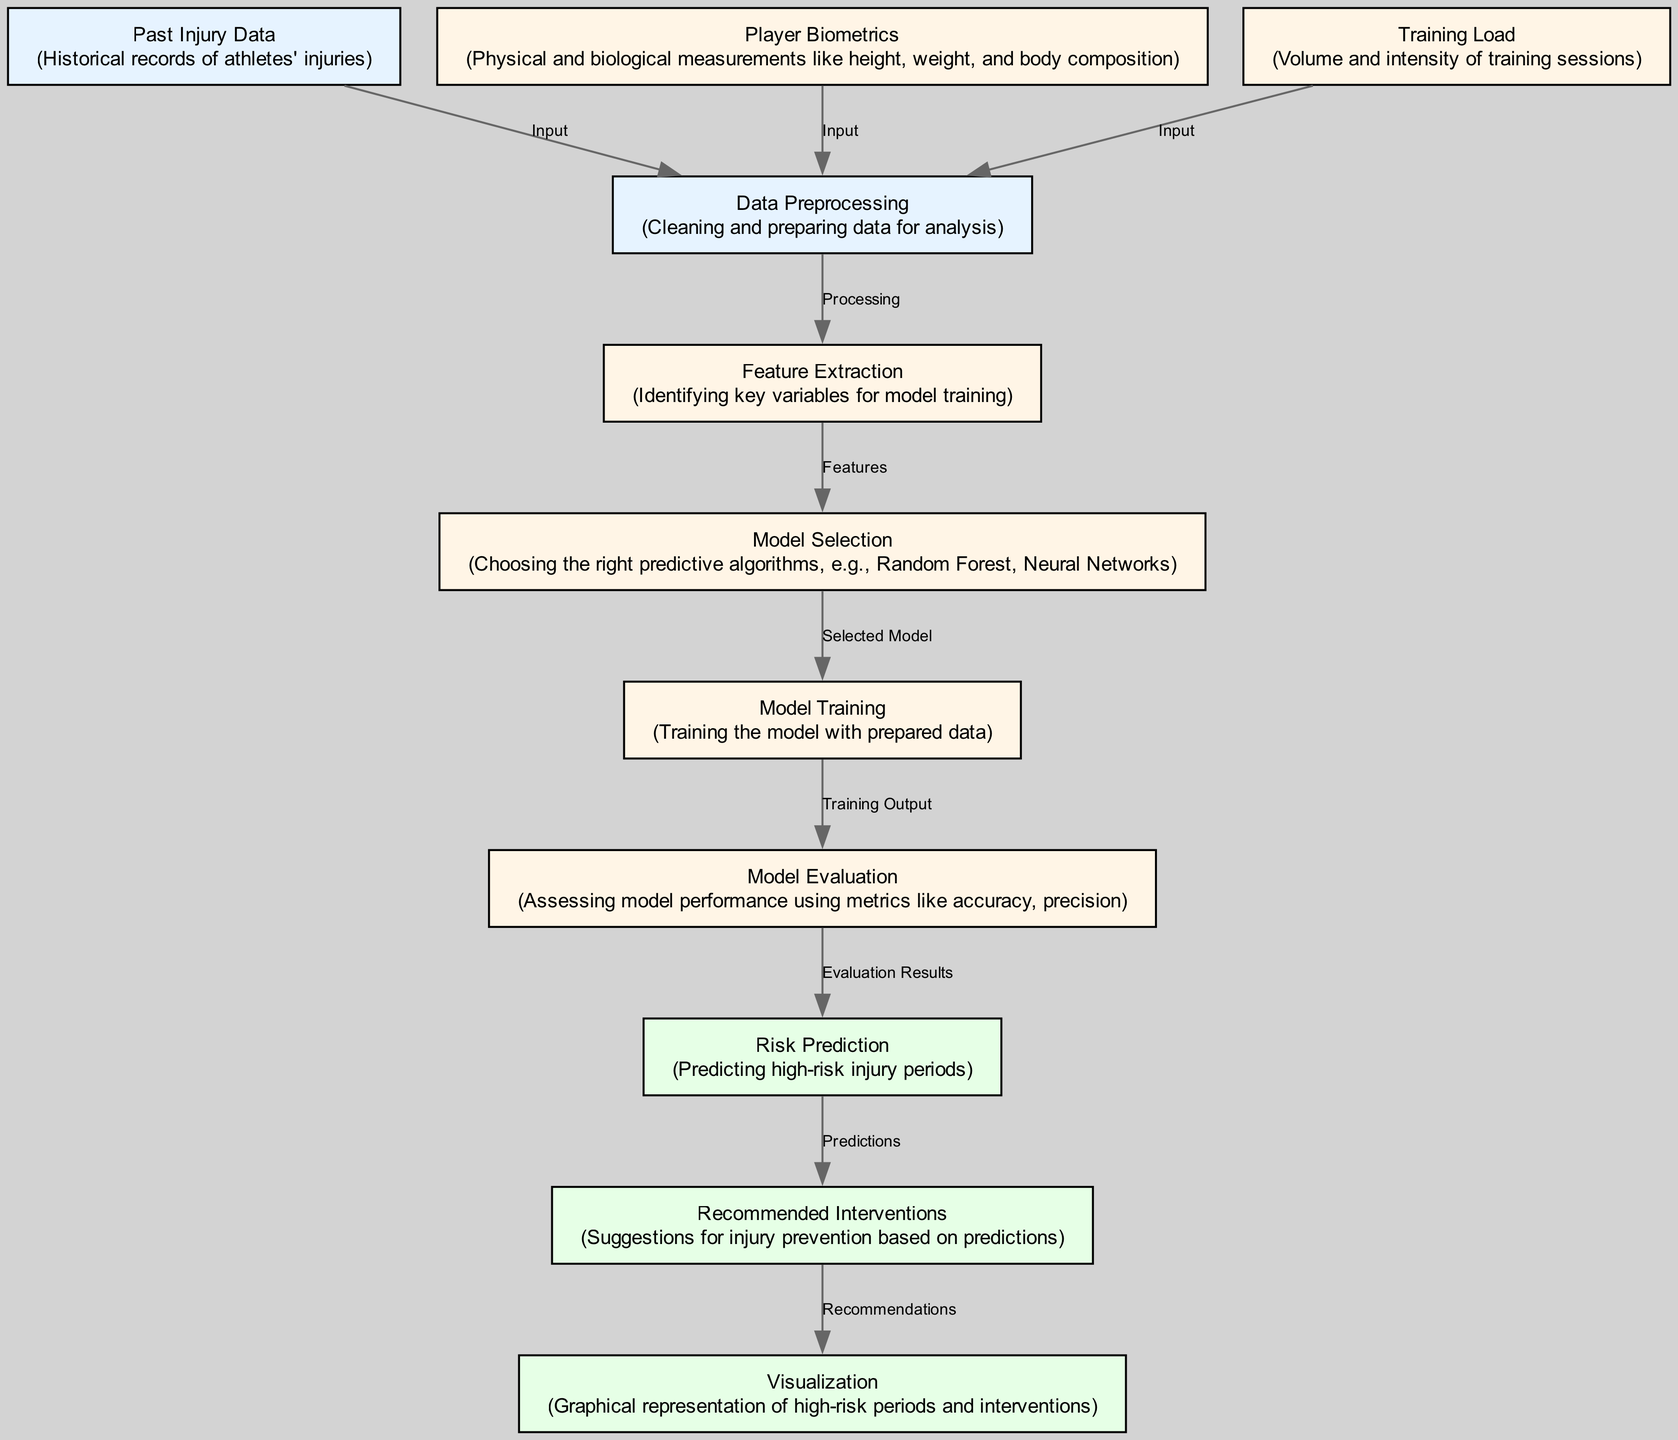What are the three types of input data for the model? The diagram lists three types of input data leading to the data preprocessing node: past injury data, player biometrics, and training load. These inputs are crucial for any predictive analysis.
Answer: Past injury data, player biometrics, training load Which node comes after data preprocessing? According to the flow of the diagram, data preprocessing leads directly to feature extraction, making it the next step in the predictive model process.
Answer: Feature extraction How many output nodes are presented in the diagram? By analyzing the diagram, we can count three output nodes: risk prediction, recommended interventions, and visualization. This indicates the final stages of processing and predictions.
Answer: Three What type of model is chosen in the model selection step? The model selection step describes the process of choosing the right predictive algorithms, specifically mentioning Random Forest and Neural Networks as options for the predictive model.
Answer: Random Forest, Neural Networks What is the primary output of the model evaluation step? Model evaluation assesses the model's performance using various metrics. The output from this process leads to the risk prediction step, indicating the model’s effectiveness in predicting injury risks.
Answer: Risk prediction Explain the relationship between risk prediction and intervention recommendation. Risk prediction is performed based on model evaluation results, and it directly influences intervention recommendation by providing predictions that help suggest appropriate injury prevention actions. This shows a clear, causal flow between these two stages.
Answer: Predictions What is the purpose of visualization in the final step? Visualization provides a graphical representation of high-risk periods and recommended interventions, making it easier for stakeholders, including athletes and managers, to understand and act on the predictive insights generated by the model.
Answer: Graphical representation Which phase comes before feature extraction? In the sequence of steps represented in the diagram, data preprocessing directly precedes feature extraction, suggesting that the data must be cleaned and prepared before identifying key variables for the model.
Answer: Data preprocessing What is the main focus of the entire predictive model? The overarching goal of the predictive model is to prevent injuries in athletes by analyzing past data, biometrics, and training loads, leading to informed recommendations for intervention based on risk predictions.
Answer: Injury prevention 